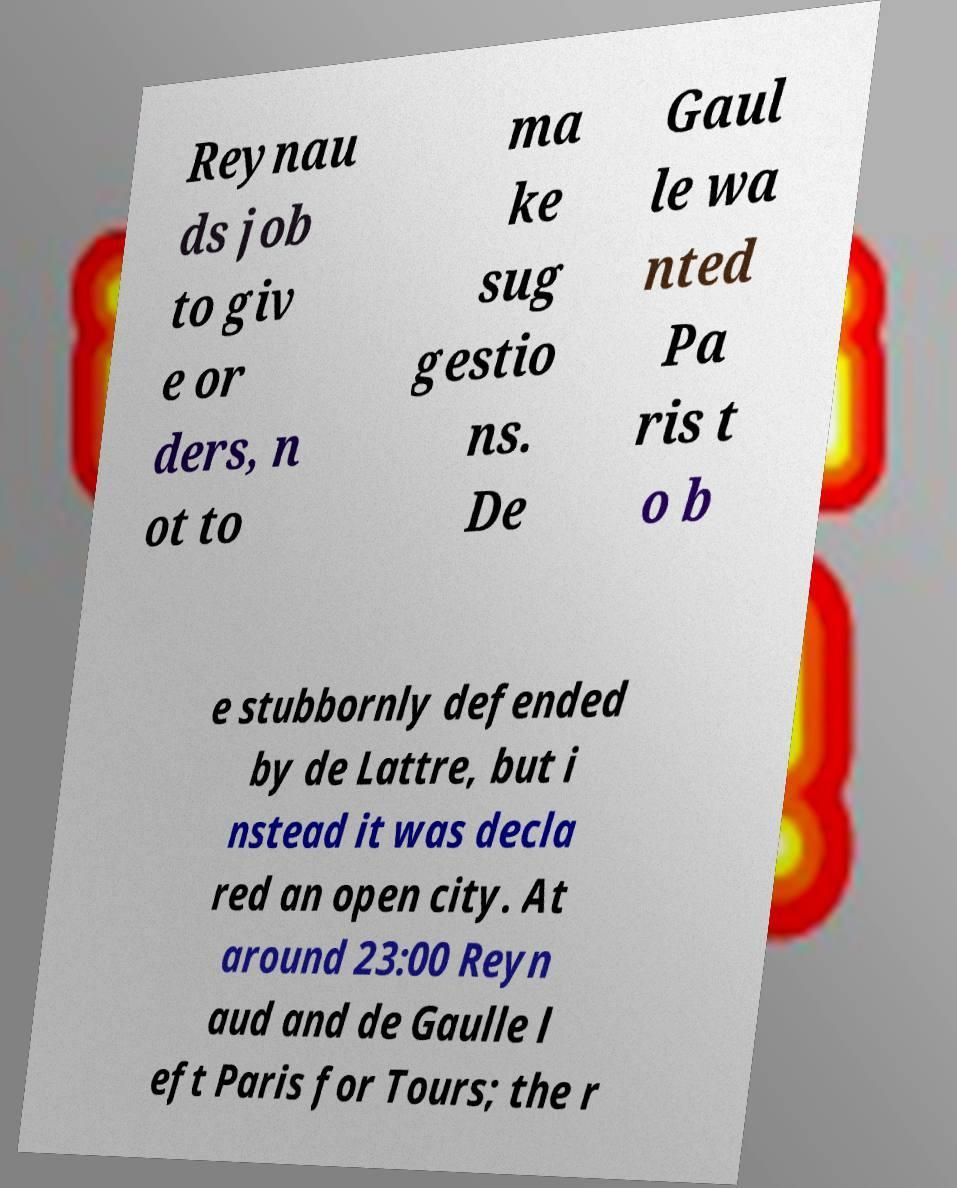Can you accurately transcribe the text from the provided image for me? Reynau ds job to giv e or ders, n ot to ma ke sug gestio ns. De Gaul le wa nted Pa ris t o b e stubbornly defended by de Lattre, but i nstead it was decla red an open city. At around 23:00 Reyn aud and de Gaulle l eft Paris for Tours; the r 